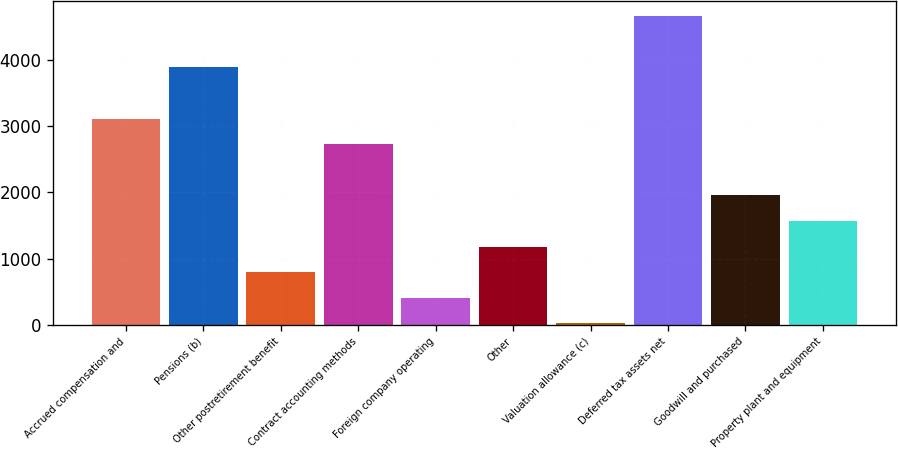Convert chart to OTSL. <chart><loc_0><loc_0><loc_500><loc_500><bar_chart><fcel>Accrued compensation and<fcel>Pensions (b)<fcel>Other postretirement benefit<fcel>Contract accounting methods<fcel>Foreign company operating<fcel>Other<fcel>Valuation allowance (c)<fcel>Deferred tax assets net<fcel>Goodwill and purchased<fcel>Property plant and equipment<nl><fcel>3116.8<fcel>3891<fcel>794.2<fcel>2729.7<fcel>407.1<fcel>1181.3<fcel>20<fcel>4665.2<fcel>1955.5<fcel>1568.4<nl></chart> 